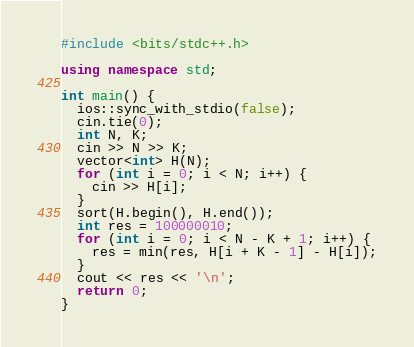Convert code to text. <code><loc_0><loc_0><loc_500><loc_500><_C++_>#include <bits/stdc++.h>

using namespace std;

int main() {
  ios::sync_with_stdio(false);
  cin.tie(0);
  int N, K;
  cin >> N >> K;
  vector<int> H(N);
  for (int i = 0; i < N; i++) {
    cin >> H[i];
  }
  sort(H.begin(), H.end());
  int res = 100000010;
  for (int i = 0; i < N - K + 1; i++) {
    res = min(res, H[i + K - 1] - H[i]);
  }
  cout << res << '\n';
  return 0;
}
</code> 